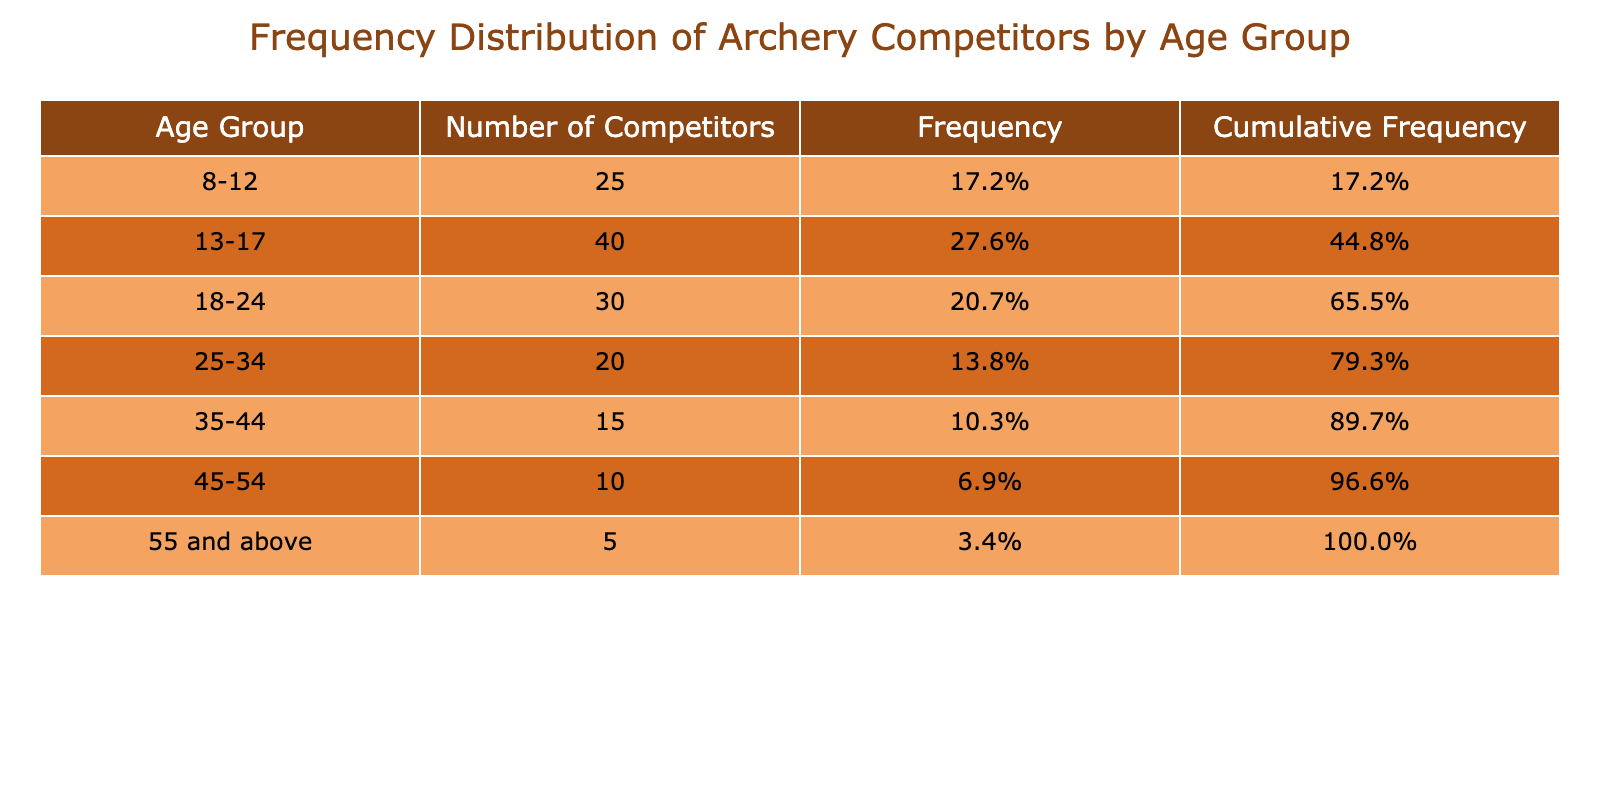What age group has the highest number of competitors? The age group with the highest number of competitors is the 13-17 group, as it shows 40 competitors, which is the largest value in the "Number of Competitors" column.
Answer: 13-17 What is the total number of competitors across all age groups? To find the total number of competitors, we add the values in the "Number of Competitors" column: 25 + 40 + 30 + 20 + 15 + 10 + 5 = 145.
Answer: 145 What percentage of competitors are in the age group 25-34? The number of competitors in the age group 25-34 is 20. To calculate the percentage, divide 20 by the total number of competitors (145) and multiply by 100: (20/145) * 100 ≈ 13.8%.
Answer: 13.8% Is it true that more than half of the competitors are aged 17 and below? To verify this, we sum the competitors in the age groups 8-12 (25) and 13-17 (40), giving us a total of 25 + 40 = 65 competitors. Since 65 is less than half of 145 (which is 72.5), the statement is false.
Answer: No How many more competitors are there in the age group 13-17 than in the 45-54 age group? The number of competitors in the age group 13-17 is 40, and in the 45-54 age group, it is 10. The difference is calculated as 40 - 10 = 30.
Answer: 30 What is the cumulative frequency for the 18-24 age group? To find the cumulative frequency for the 18-24 age group, we need to sum the frequencies of all preceding groups: 25 (8-12) + 40 (13-17) + 30 (18-24) = 95. Therefore, the cumulative frequency at this age group is 95/145 ≈ 65.5%.
Answer: 65.5% Which age group has the fewest competitors? The age group with the fewest competitors is the "55 and above" group, which shows only 5 competitors in the "Number of Competitors" column, the smallest value among all groups.
Answer: 55 and above What is the average number of competitors across all age groups? To find the average, we sum the number of competitors (145) and divide by the number of age groups (7): 145 / 7 ≈ 20.7.
Answer: 20.7 What cumulative frequency percentage do competitors aged 35-44 contribute to the total? To find the cumulative frequency for the 35-44 age group, sum the frequencies of all age groups before it: 25 (8-12) + 40 (13-17) + 30 (18-24) + 20 (25-34) + 15 (35-44) = 130. The cumulative frequency percentage is 130/145 ≈ 89.7%.
Answer: 89.7% 